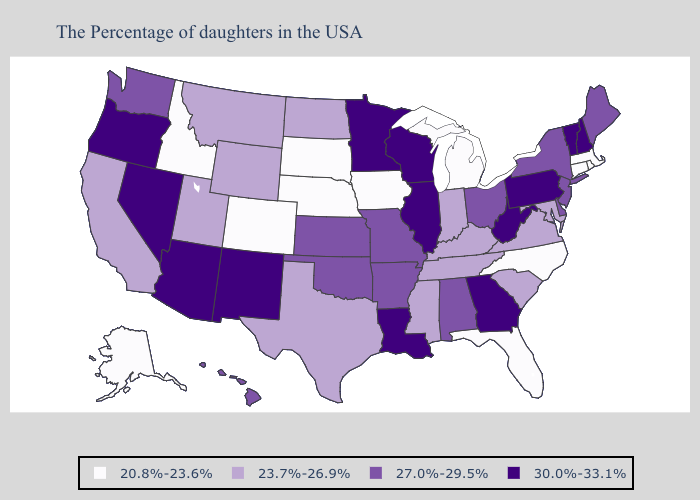What is the highest value in the USA?
Short answer required. 30.0%-33.1%. Which states have the highest value in the USA?
Keep it brief. New Hampshire, Vermont, Pennsylvania, West Virginia, Georgia, Wisconsin, Illinois, Louisiana, Minnesota, New Mexico, Arizona, Nevada, Oregon. Among the states that border Utah , does Idaho have the highest value?
Keep it brief. No. Among the states that border Illinois , does Iowa have the lowest value?
Keep it brief. Yes. What is the lowest value in states that border South Dakota?
Keep it brief. 20.8%-23.6%. What is the highest value in the Northeast ?
Answer briefly. 30.0%-33.1%. Name the states that have a value in the range 27.0%-29.5%?
Keep it brief. Maine, New York, New Jersey, Delaware, Ohio, Alabama, Missouri, Arkansas, Kansas, Oklahoma, Washington, Hawaii. How many symbols are there in the legend?
Concise answer only. 4. Is the legend a continuous bar?
Give a very brief answer. No. What is the value of Montana?
Keep it brief. 23.7%-26.9%. Name the states that have a value in the range 23.7%-26.9%?
Keep it brief. Maryland, Virginia, South Carolina, Kentucky, Indiana, Tennessee, Mississippi, Texas, North Dakota, Wyoming, Utah, Montana, California. Name the states that have a value in the range 23.7%-26.9%?
Give a very brief answer. Maryland, Virginia, South Carolina, Kentucky, Indiana, Tennessee, Mississippi, Texas, North Dakota, Wyoming, Utah, Montana, California. Does Minnesota have a lower value than Montana?
Keep it brief. No. What is the value of Tennessee?
Answer briefly. 23.7%-26.9%. Which states have the lowest value in the MidWest?
Quick response, please. Michigan, Iowa, Nebraska, South Dakota. 